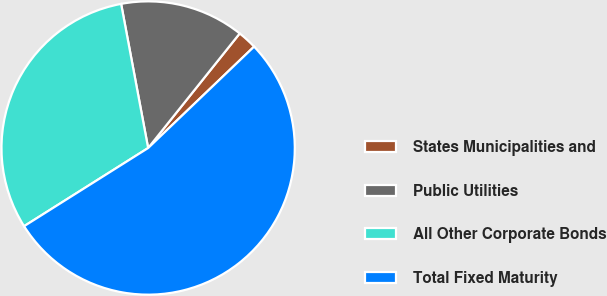Convert chart to OTSL. <chart><loc_0><loc_0><loc_500><loc_500><pie_chart><fcel>States Municipalities and<fcel>Public Utilities<fcel>All Other Corporate Bonds<fcel>Total Fixed Maturity<nl><fcel>2.12%<fcel>13.68%<fcel>31.0%<fcel>53.2%<nl></chart> 